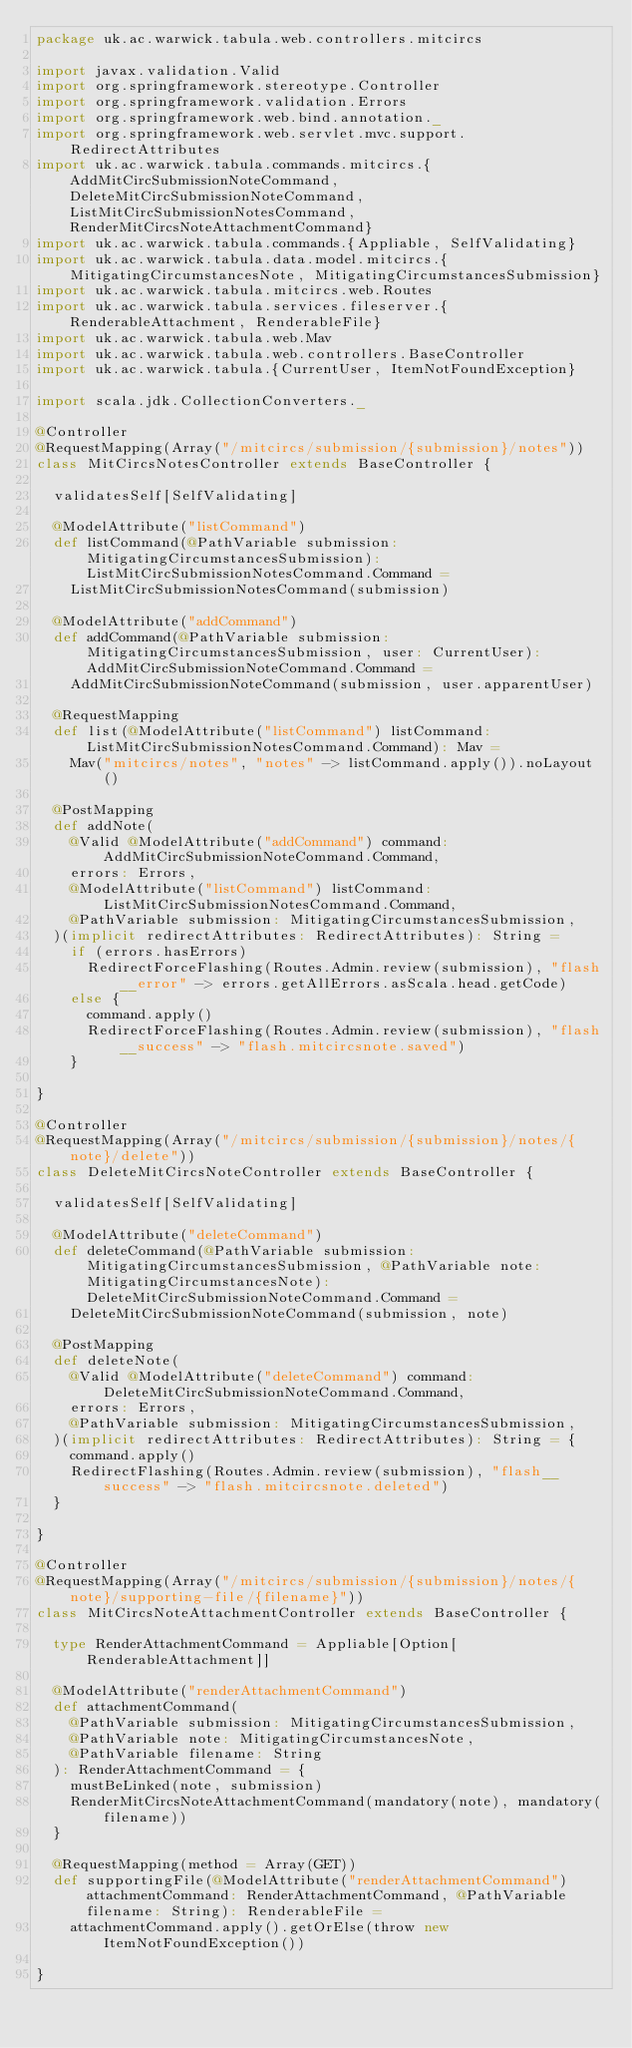<code> <loc_0><loc_0><loc_500><loc_500><_Scala_>package uk.ac.warwick.tabula.web.controllers.mitcircs

import javax.validation.Valid
import org.springframework.stereotype.Controller
import org.springframework.validation.Errors
import org.springframework.web.bind.annotation._
import org.springframework.web.servlet.mvc.support.RedirectAttributes
import uk.ac.warwick.tabula.commands.mitcircs.{AddMitCircSubmissionNoteCommand, DeleteMitCircSubmissionNoteCommand, ListMitCircSubmissionNotesCommand, RenderMitCircsNoteAttachmentCommand}
import uk.ac.warwick.tabula.commands.{Appliable, SelfValidating}
import uk.ac.warwick.tabula.data.model.mitcircs.{MitigatingCircumstancesNote, MitigatingCircumstancesSubmission}
import uk.ac.warwick.tabula.mitcircs.web.Routes
import uk.ac.warwick.tabula.services.fileserver.{RenderableAttachment, RenderableFile}
import uk.ac.warwick.tabula.web.Mav
import uk.ac.warwick.tabula.web.controllers.BaseController
import uk.ac.warwick.tabula.{CurrentUser, ItemNotFoundException}

import scala.jdk.CollectionConverters._

@Controller
@RequestMapping(Array("/mitcircs/submission/{submission}/notes"))
class MitCircsNotesController extends BaseController {

  validatesSelf[SelfValidating]

  @ModelAttribute("listCommand")
  def listCommand(@PathVariable submission: MitigatingCircumstancesSubmission): ListMitCircSubmissionNotesCommand.Command =
    ListMitCircSubmissionNotesCommand(submission)

  @ModelAttribute("addCommand")
  def addCommand(@PathVariable submission: MitigatingCircumstancesSubmission, user: CurrentUser): AddMitCircSubmissionNoteCommand.Command =
    AddMitCircSubmissionNoteCommand(submission, user.apparentUser)

  @RequestMapping
  def list(@ModelAttribute("listCommand") listCommand: ListMitCircSubmissionNotesCommand.Command): Mav =
    Mav("mitcircs/notes", "notes" -> listCommand.apply()).noLayout()

  @PostMapping
  def addNote(
    @Valid @ModelAttribute("addCommand") command: AddMitCircSubmissionNoteCommand.Command,
    errors: Errors,
    @ModelAttribute("listCommand") listCommand: ListMitCircSubmissionNotesCommand.Command,
    @PathVariable submission: MitigatingCircumstancesSubmission,
  )(implicit redirectAttributes: RedirectAttributes): String =
    if (errors.hasErrors)
      RedirectForceFlashing(Routes.Admin.review(submission), "flash__error" -> errors.getAllErrors.asScala.head.getCode)
    else {
      command.apply()
      RedirectForceFlashing(Routes.Admin.review(submission), "flash__success" -> "flash.mitcircsnote.saved")
    }

}

@Controller
@RequestMapping(Array("/mitcircs/submission/{submission}/notes/{note}/delete"))
class DeleteMitCircsNoteController extends BaseController {

  validatesSelf[SelfValidating]

  @ModelAttribute("deleteCommand")
  def deleteCommand(@PathVariable submission: MitigatingCircumstancesSubmission, @PathVariable note: MitigatingCircumstancesNote): DeleteMitCircSubmissionNoteCommand.Command =
    DeleteMitCircSubmissionNoteCommand(submission, note)

  @PostMapping
  def deleteNote(
    @Valid @ModelAttribute("deleteCommand") command: DeleteMitCircSubmissionNoteCommand.Command,
    errors: Errors,
    @PathVariable submission: MitigatingCircumstancesSubmission,
  )(implicit redirectAttributes: RedirectAttributes): String = {
    command.apply()
    RedirectFlashing(Routes.Admin.review(submission), "flash__success" -> "flash.mitcircsnote.deleted")
  }

}

@Controller
@RequestMapping(Array("/mitcircs/submission/{submission}/notes/{note}/supporting-file/{filename}"))
class MitCircsNoteAttachmentController extends BaseController {

  type RenderAttachmentCommand = Appliable[Option[RenderableAttachment]]

  @ModelAttribute("renderAttachmentCommand")
  def attachmentCommand(
    @PathVariable submission: MitigatingCircumstancesSubmission,
    @PathVariable note: MitigatingCircumstancesNote,
    @PathVariable filename: String
  ): RenderAttachmentCommand = {
    mustBeLinked(note, submission)
    RenderMitCircsNoteAttachmentCommand(mandatory(note), mandatory(filename))
  }

  @RequestMapping(method = Array(GET))
  def supportingFile(@ModelAttribute("renderAttachmentCommand") attachmentCommand: RenderAttachmentCommand, @PathVariable filename: String): RenderableFile =
    attachmentCommand.apply().getOrElse(throw new ItemNotFoundException())

}
</code> 